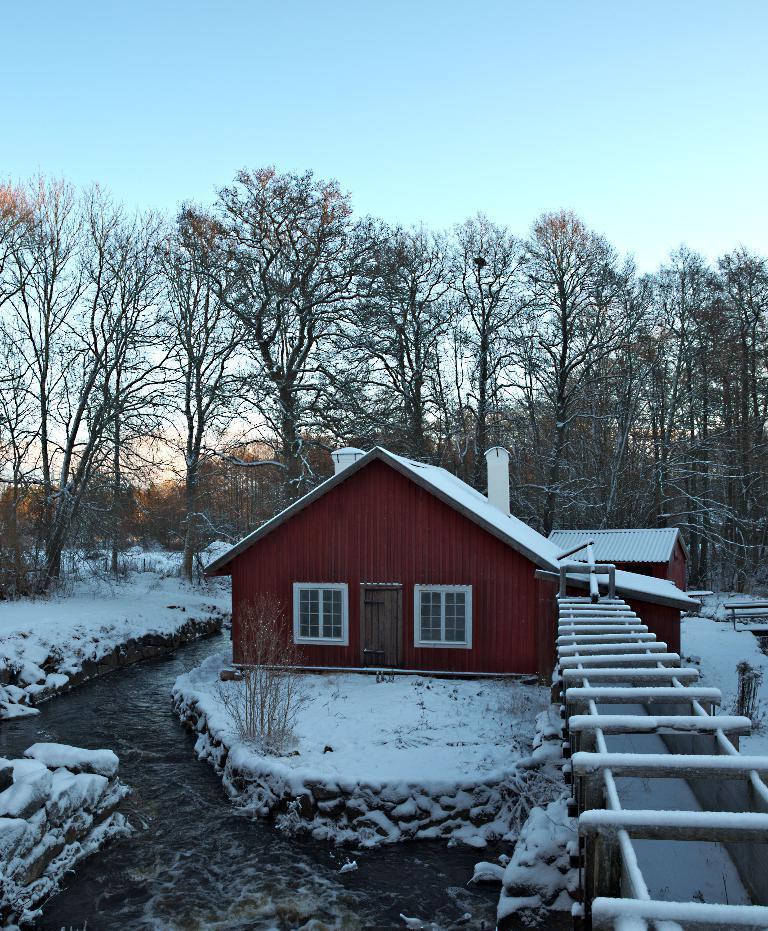In one or two sentences, can you explain what this image depicts? In this image I can see ground full of snow and few houses in the centre. On the left and in the front of this image I can see water. In the background I can see number of trees and the sky. 